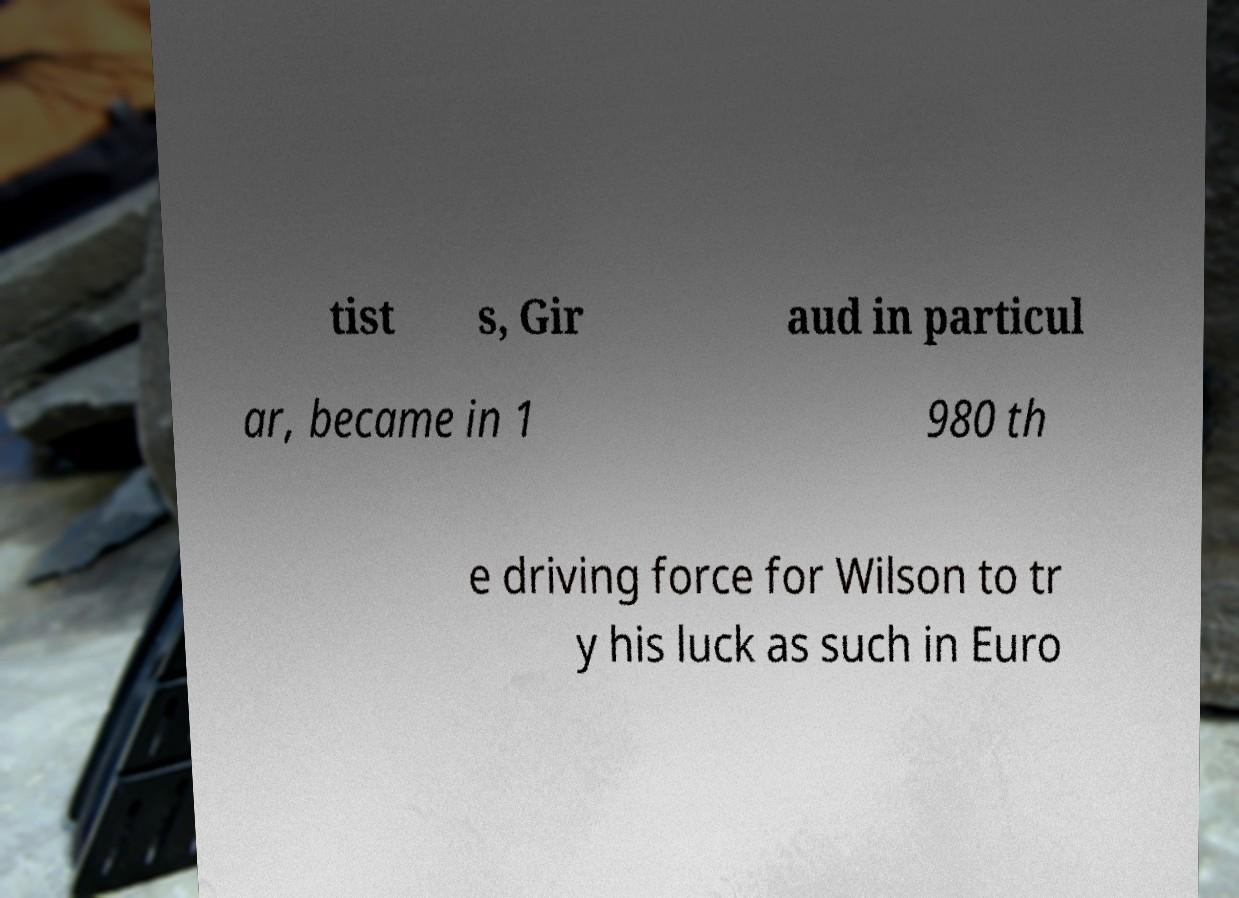What messages or text are displayed in this image? I need them in a readable, typed format. tist s, Gir aud in particul ar, became in 1 980 th e driving force for Wilson to tr y his luck as such in Euro 